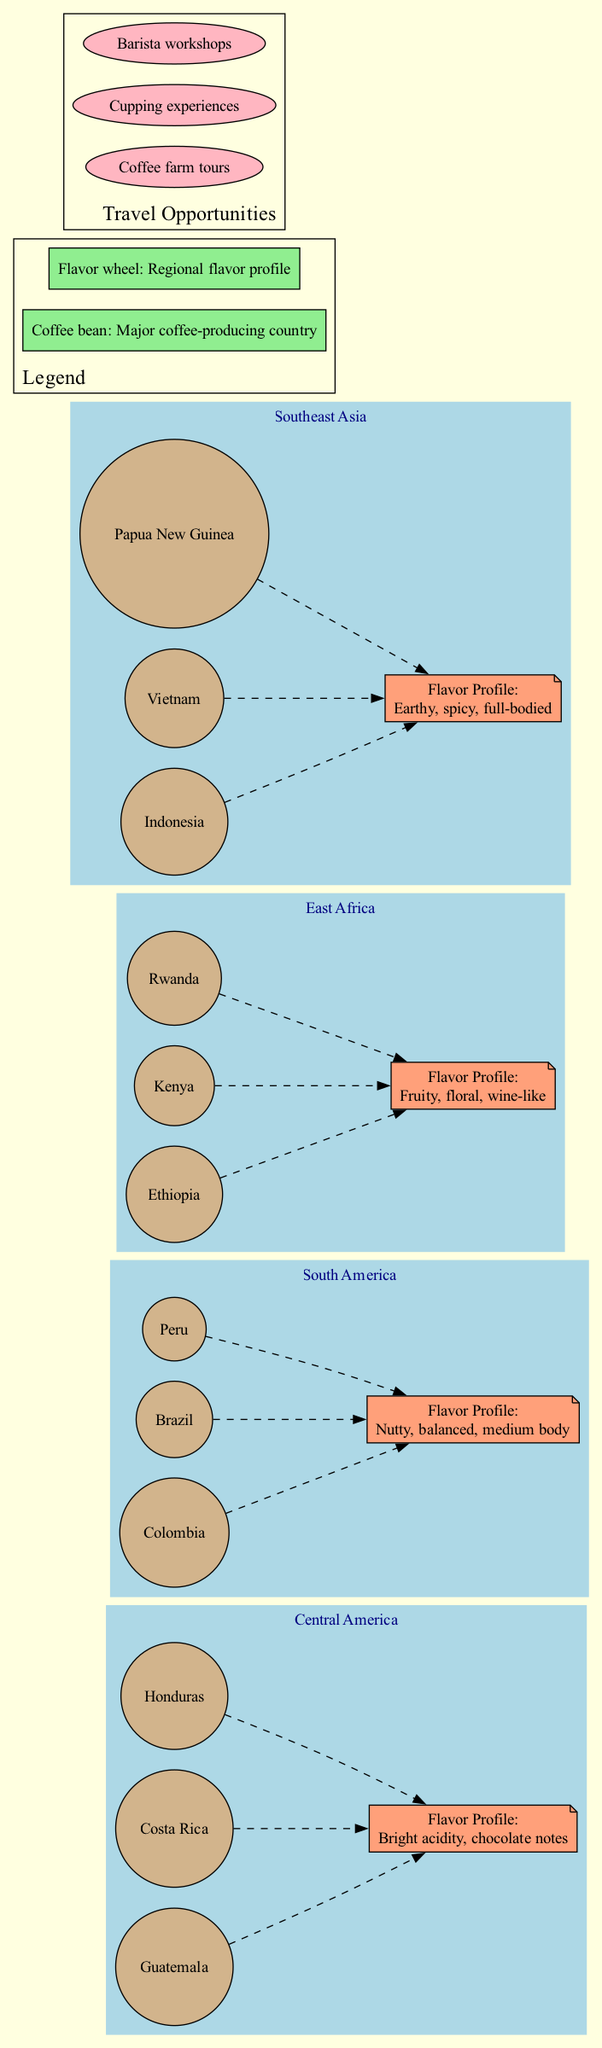What are the three countries in Central America? The diagram lists Guatemala, Costa Rica, and Honduras as the major coffee-producing countries in Central America.
Answer: Guatemala, Costa Rica, Honduras What flavor profile is associated with South America? The flavor profile for South America is described as nutty, balanced, and medium body, according to the diagram.
Answer: Nutty, balanced, medium body How many main regions are displayed in the diagram? The diagram shows four main regions: Central America, South America, East Africa, and Southeast Asia. Counting them provides the answer.
Answer: Four Which region has a flavor profile described as fruity, floral, and wine-like? By looking at the flavor profiles listed in the regions, East Africa is specifically noted for having a fruity, floral, and wine-like flavor profile.
Answer: East Africa What is one travel opportunity mentioned in the diagram? The diagram provides travel opportunities, and one of these is "Coffee farm tours," which can be directly found in the travel opportunities section.
Answer: Coffee farm tours Which countries are associated with the flavor profile of earthy, spicy, full-bodied? Southeast Asia is associated with the flavor profile of earthy, spicy, full-bodied, according to the flavor descriptions in the diagram. The diagram should be examined for specific countries.
Answer: Indonesia, Vietnam, Papua New Guinea What is the icon used for indicating major coffee-producing countries? The diagram includes a legend indicating that the coffee bean icon represents major coffee-producing countries. This information can be found in the legend section.
Answer: Coffee bean How many travel opportunities are listed in the diagram? The diagram lists three travel opportunities; thus, counting them directly provides the answer.
Answer: Three 